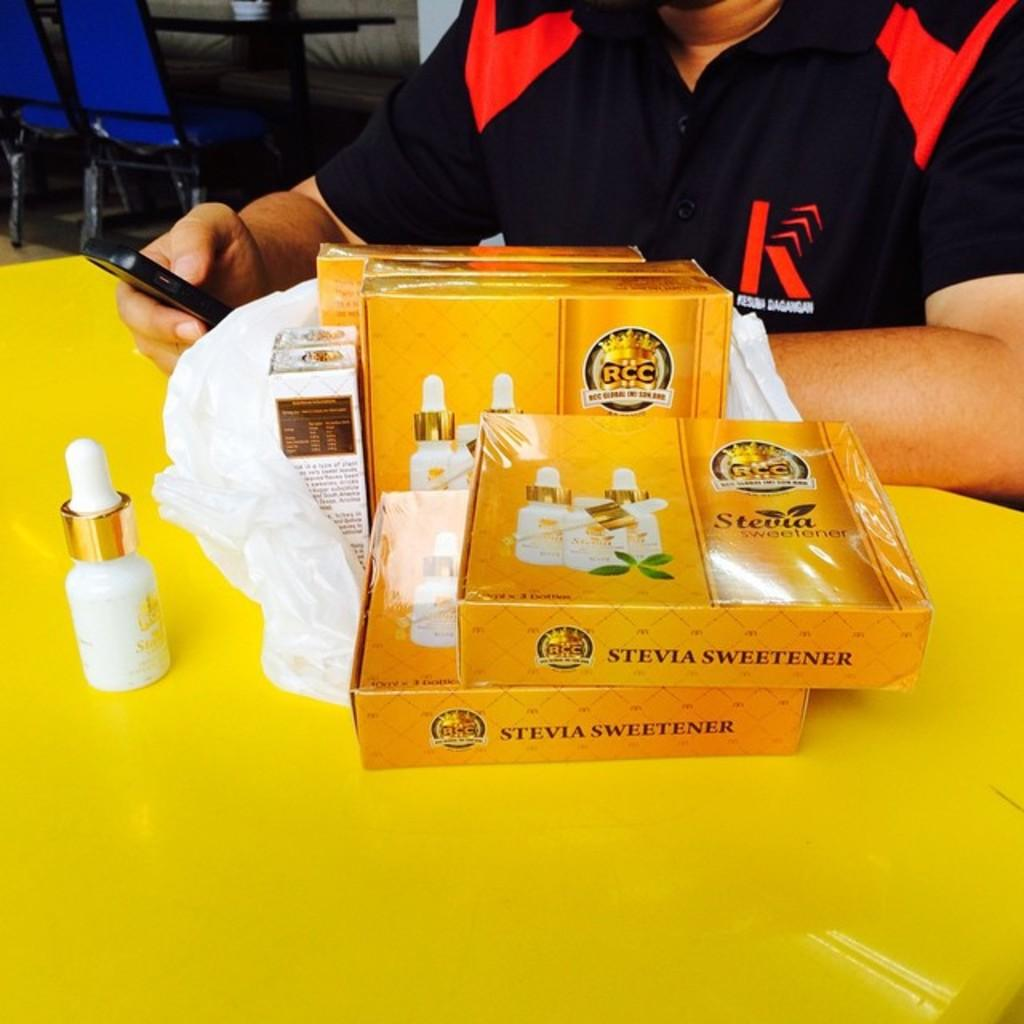Provide a one-sentence caption for the provided image. Packages of Stevia are displayed on a yellow table in front of a person wearing a black and red shirt. 